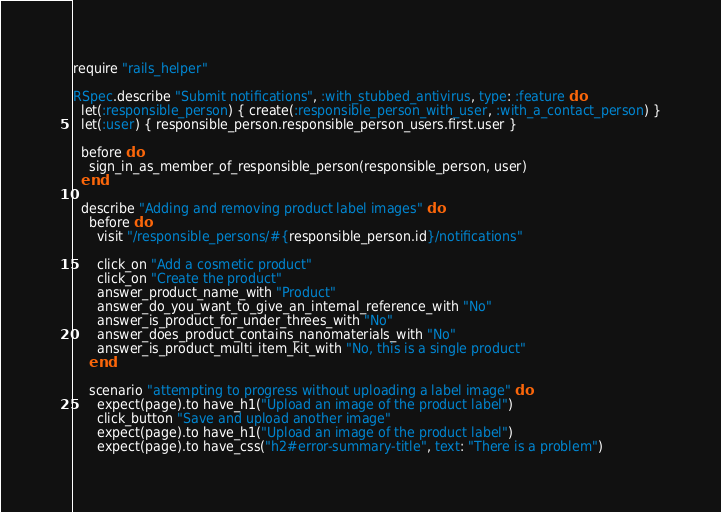Convert code to text. <code><loc_0><loc_0><loc_500><loc_500><_Ruby_>require "rails_helper"

RSpec.describe "Submit notifications", :with_stubbed_antivirus, type: :feature do
  let(:responsible_person) { create(:responsible_person_with_user, :with_a_contact_person) }
  let(:user) { responsible_person.responsible_person_users.first.user }

  before do
    sign_in_as_member_of_responsible_person(responsible_person, user)
  end

  describe "Adding and removing product label images" do
    before do
      visit "/responsible_persons/#{responsible_person.id}/notifications"

      click_on "Add a cosmetic product"
      click_on "Create the product"
      answer_product_name_with "Product"
      answer_do_you_want_to_give_an_internal_reference_with "No"
      answer_is_product_for_under_threes_with "No"
      answer_does_product_contains_nanomaterials_with "No"
      answer_is_product_multi_item_kit_with "No, this is a single product"
    end

    scenario "attempting to progress without uploading a label image" do
      expect(page).to have_h1("Upload an image of the product label")
      click_button "Save and upload another image"
      expect(page).to have_h1("Upload an image of the product label")
      expect(page).to have_css("h2#error-summary-title", text: "There is a problem")</code> 